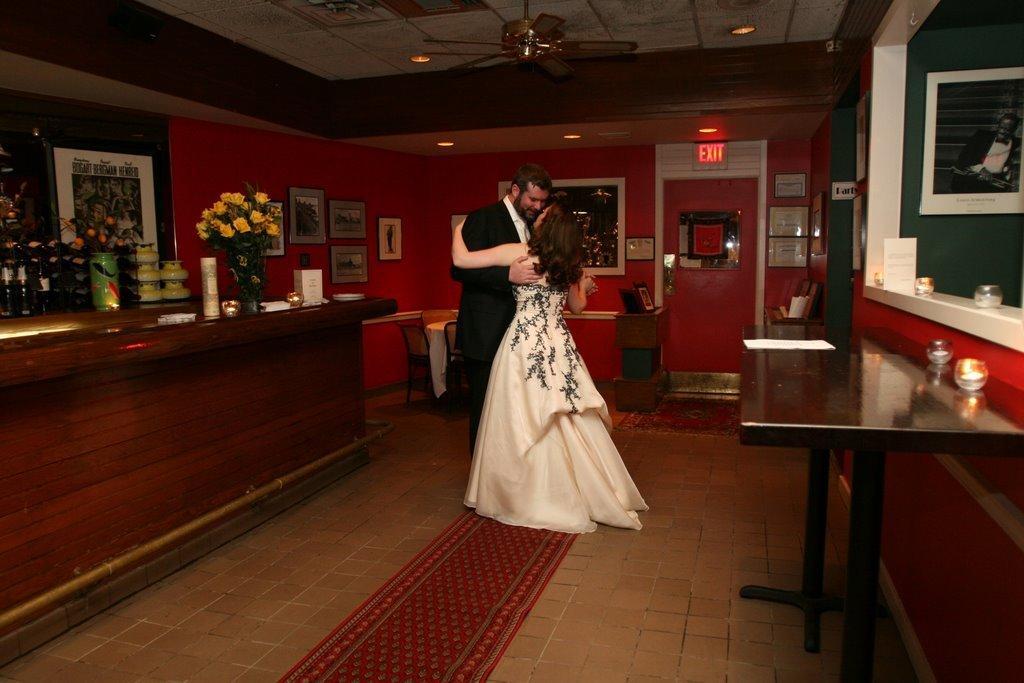Could you give a brief overview of what you see in this image? In this image there is a man in the middle who is wearing the black suit is hugging the girl who is wearing the white dress. At the top there is ceiling with the lights and a fan. On the right side there is a desk on which there are cups. There is a picture attached to the wall. In the background there is a door, above the door there is an exit board. Beside the door there are two frames attached to the wall. On the left side there is a desk on which there is a flower vase,boxes and lights. Beside the desk there are bowls,jars on the table. In the background there is a wall on which there are photo frames. At the bottom there is a carpet. There are few boxes kept on the floor. On the left side there are chairs. 